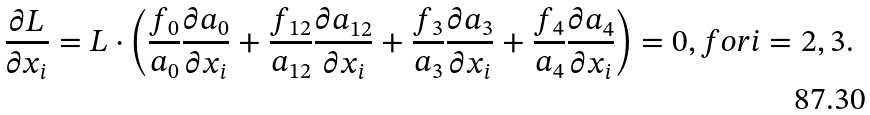<formula> <loc_0><loc_0><loc_500><loc_500>\frac { \partial L } { \partial x _ { i } } = L \cdot \left ( \frac { f _ { 0 } } { a _ { 0 } } \frac { \partial a _ { 0 } } { \partial x _ { i } } + \frac { f _ { 1 2 } } { a _ { 1 2 } } \frac { \partial a _ { 1 2 } } { \partial x _ { i } } + \frac { f _ { 3 } } { a _ { 3 } } \frac { \partial a _ { 3 } } { \partial x _ { i } } + \frac { f _ { 4 } } { a _ { 4 } } \frac { \partial a _ { 4 } } { \partial x _ { i } } \right ) = 0 , f o r i = 2 , 3 .</formula> 